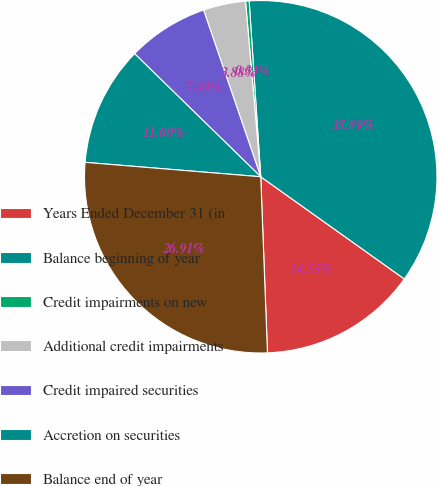Convert chart. <chart><loc_0><loc_0><loc_500><loc_500><pie_chart><fcel>Years Ended December 31 (in<fcel>Balance beginning of year<fcel>Credit impairments on new<fcel>Additional credit impairments<fcel>Credit impaired securities<fcel>Accretion on securities<fcel>Balance end of year<nl><fcel>14.55%<fcel>35.89%<fcel>0.33%<fcel>3.88%<fcel>7.44%<fcel>11.0%<fcel>26.91%<nl></chart> 